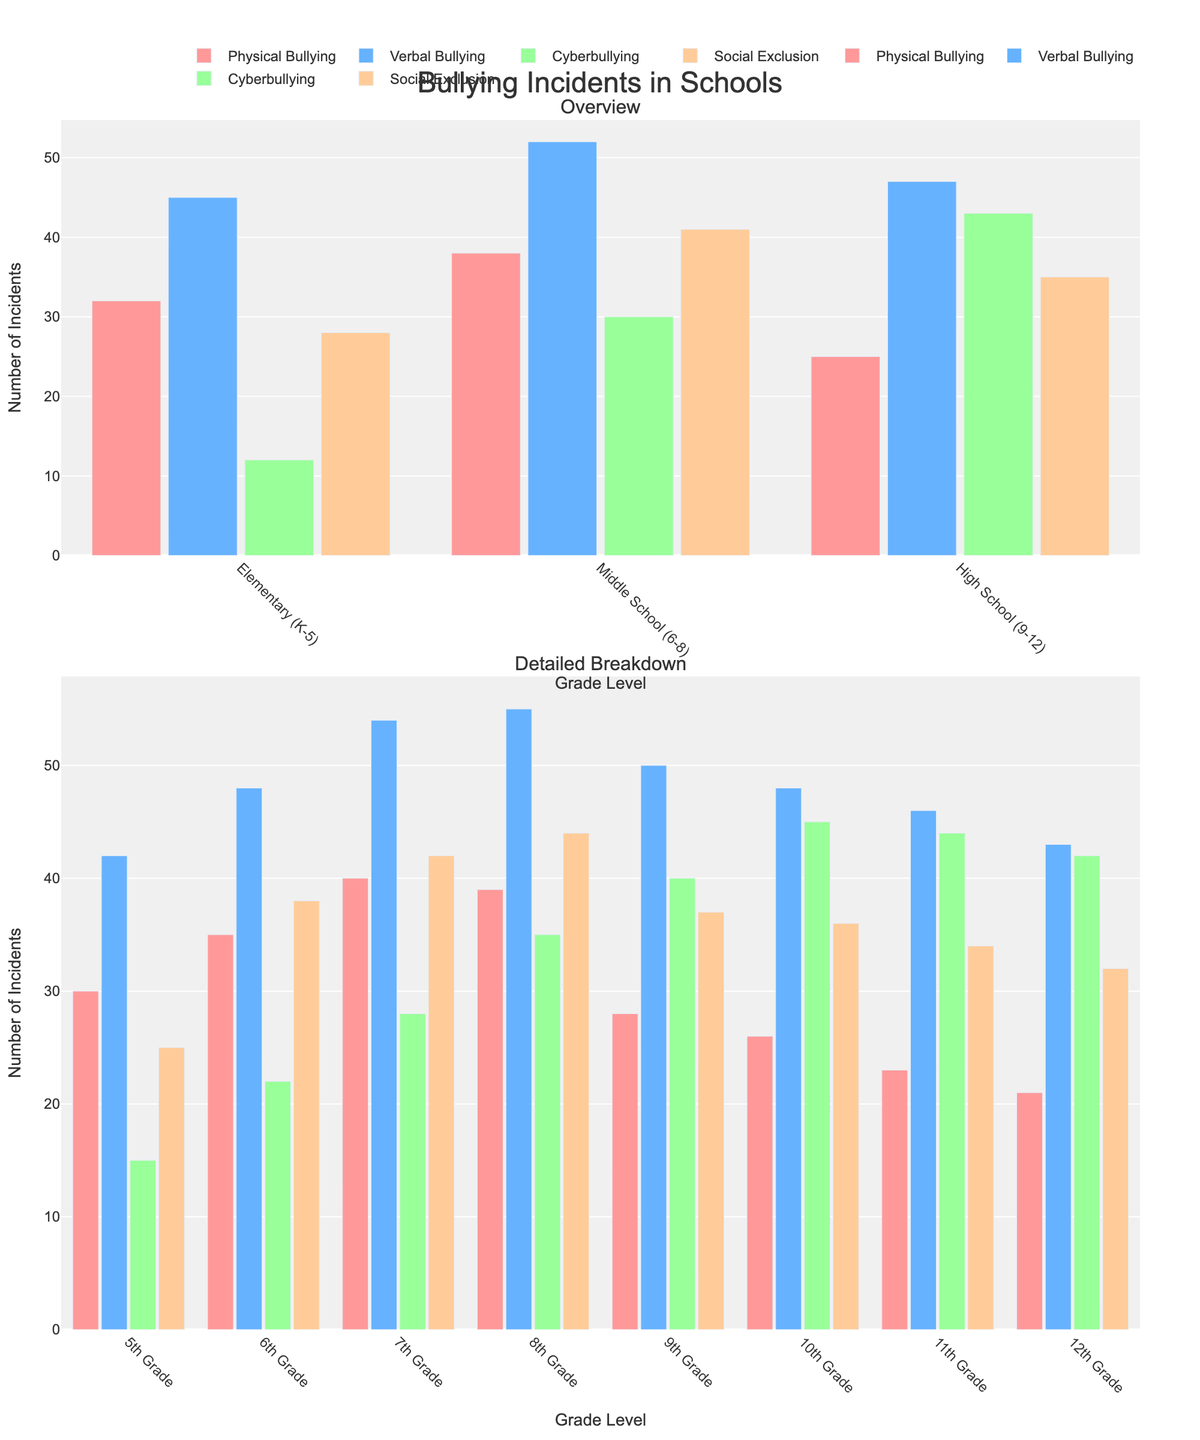Which grade level reports the highest number of physical bullying incidents? Looking at the bars for each grade level under the "Physical Bullying" category, Middle School (6-8) has the tallest bar, hence the highest number of incidents.
Answer: Middle School (6-8) Which type of bullying is more frequent in high school compared to elementary school? Comparing the height of the bars for each type of bullying between High School (9-12) and Elementary (K-5), Cyberbullying is more frequent in high school.
Answer: Cyberbullying Among 9th, 10th, and 11th grades, which has the highest number of social exclusion incidents? Observing the bars under the "Social Exclusion" category for 9th, 10th, and 11th grades, 9th grade has the tallest bar.
Answer: 9th Grade What's the average number of verbal bullying incidents reported for elementary, middle, and high schools? Summing up the verbal bullying incidents for Elementary (45), Middle School (52), and High School (47) gives 144. Dividing this by 3 yields the average.
Answer: 48 How does the frequency of cyberbullying incidents in 7th grade compare to 10th grade? By comparing the heights of the bars for "Cyberbullying" in 7th grade (28) and 10th grade (45), we see that 10th grade has more incidents.
Answer: 10th Grade has more Which type of bullying has the smallest difference in frequency between the 12th grade and elementary school levels? Subtracting frequencies for each category between 12th grade and Elementary: Physical Bullying (32-21=11), Verbal Bullying (45-43=2), Cyberbullying (12-42=30), Social Exclusion (28-32=4). The smallest difference is in Verbal Bullying.
Answer: Verbal Bullying By how much does the number of physical bullying incidents in 6th grade exceed that in 5th grade? Subtracting the number of physical bullying incidents in 5th grade (30) from that in 6th grade (35), we get the difference.
Answer: 5 Which category of bullying has the highest average frequency across all specified grades? Summing the incidents across all grades for each category and then dividing by the number of grades (11), we get: Physical Bullying (309/11), Verbal Bullying (529/11), Cyberbullying (334/11), Social Exclusion (392/11). Verbal Bullying has the highest average frequency.
Answer: Verbal Bullying 